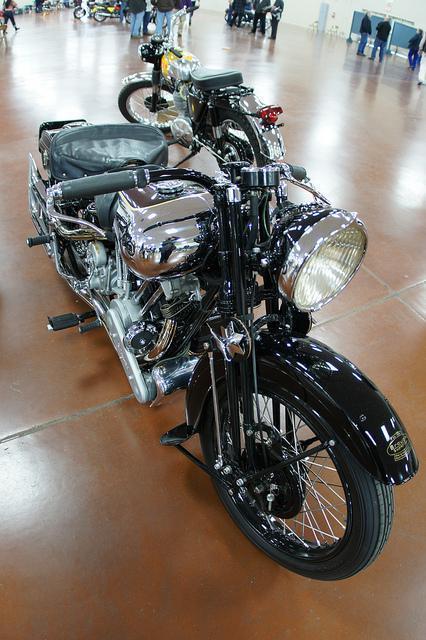How many motorcycles can you see?
Give a very brief answer. 2. 